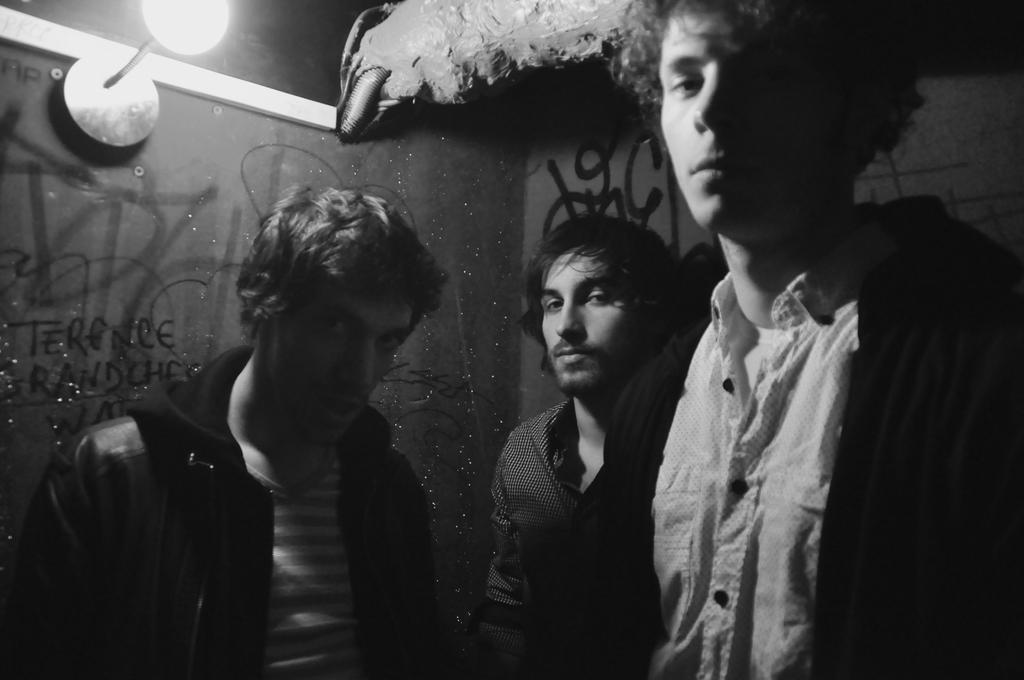How would you summarize this image in a sentence or two? It is the black and white image in which we can see there are three men in the middle. On the left side top there is a light. There is a painting on the wall. At the top there is a pipe. 